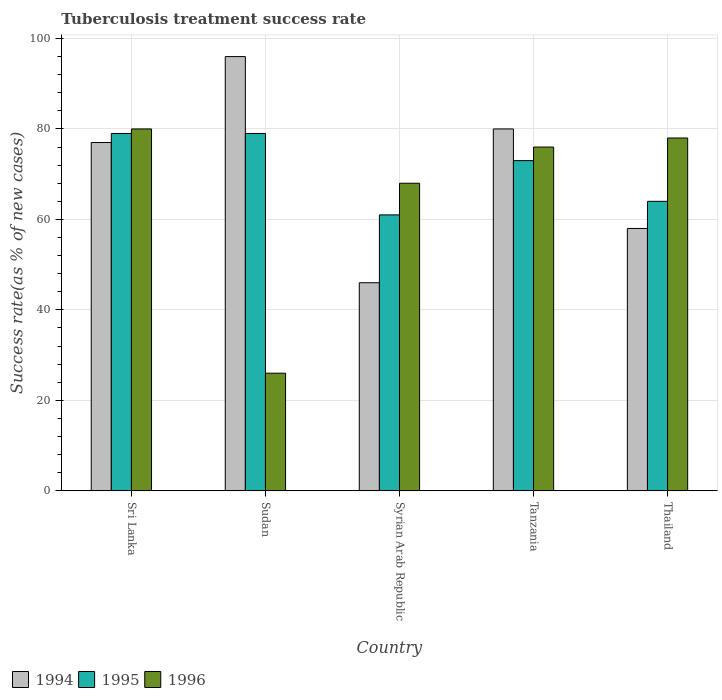How many groups of bars are there?
Make the answer very short. 5. How many bars are there on the 3rd tick from the left?
Keep it short and to the point. 3. How many bars are there on the 5th tick from the right?
Make the answer very short. 3. What is the label of the 4th group of bars from the left?
Give a very brief answer. Tanzania. Across all countries, what is the maximum tuberculosis treatment success rate in 1994?
Your answer should be very brief. 96. Across all countries, what is the minimum tuberculosis treatment success rate in 1995?
Offer a very short reply. 61. In which country was the tuberculosis treatment success rate in 1995 maximum?
Offer a very short reply. Sri Lanka. In which country was the tuberculosis treatment success rate in 1996 minimum?
Ensure brevity in your answer.  Sudan. What is the total tuberculosis treatment success rate in 1995 in the graph?
Ensure brevity in your answer.  356. What is the average tuberculosis treatment success rate in 1996 per country?
Keep it short and to the point. 65.6. What is the difference between the tuberculosis treatment success rate of/in 1995 and tuberculosis treatment success rate of/in 1996 in Syrian Arab Republic?
Make the answer very short. -7. What is the ratio of the tuberculosis treatment success rate in 1996 in Sudan to that in Tanzania?
Give a very brief answer. 0.34. Is the difference between the tuberculosis treatment success rate in 1995 in Syrian Arab Republic and Thailand greater than the difference between the tuberculosis treatment success rate in 1996 in Syrian Arab Republic and Thailand?
Provide a short and direct response. Yes. What is the difference between the highest and the lowest tuberculosis treatment success rate in 1994?
Provide a short and direct response. 50. Is the sum of the tuberculosis treatment success rate in 1995 in Sri Lanka and Thailand greater than the maximum tuberculosis treatment success rate in 1994 across all countries?
Your response must be concise. Yes. What does the 2nd bar from the left in Tanzania represents?
Offer a very short reply. 1995. What does the 2nd bar from the right in Sudan represents?
Make the answer very short. 1995. Is it the case that in every country, the sum of the tuberculosis treatment success rate in 1995 and tuberculosis treatment success rate in 1994 is greater than the tuberculosis treatment success rate in 1996?
Give a very brief answer. Yes. How many bars are there?
Your answer should be very brief. 15. Are all the bars in the graph horizontal?
Provide a succinct answer. No. Does the graph contain any zero values?
Your answer should be compact. No. Where does the legend appear in the graph?
Your response must be concise. Bottom left. How many legend labels are there?
Ensure brevity in your answer.  3. How are the legend labels stacked?
Offer a very short reply. Horizontal. What is the title of the graph?
Ensure brevity in your answer.  Tuberculosis treatment success rate. What is the label or title of the Y-axis?
Offer a terse response. Success rate(as % of new cases). What is the Success rate(as % of new cases) of 1995 in Sri Lanka?
Offer a very short reply. 79. What is the Success rate(as % of new cases) of 1996 in Sri Lanka?
Offer a terse response. 80. What is the Success rate(as % of new cases) in 1994 in Sudan?
Your answer should be compact. 96. What is the Success rate(as % of new cases) of 1995 in Sudan?
Your answer should be compact. 79. What is the Success rate(as % of new cases) of 1996 in Sudan?
Your response must be concise. 26. What is the Success rate(as % of new cases) in 1994 in Tanzania?
Your answer should be very brief. 80. What is the Success rate(as % of new cases) in 1995 in Tanzania?
Provide a succinct answer. 73. What is the Success rate(as % of new cases) of 1996 in Tanzania?
Your response must be concise. 76. What is the Success rate(as % of new cases) of 1994 in Thailand?
Keep it short and to the point. 58. What is the Success rate(as % of new cases) in 1996 in Thailand?
Ensure brevity in your answer.  78. Across all countries, what is the maximum Success rate(as % of new cases) in 1994?
Provide a succinct answer. 96. Across all countries, what is the maximum Success rate(as % of new cases) of 1995?
Your answer should be very brief. 79. Across all countries, what is the minimum Success rate(as % of new cases) of 1996?
Make the answer very short. 26. What is the total Success rate(as % of new cases) of 1994 in the graph?
Your answer should be compact. 357. What is the total Success rate(as % of new cases) in 1995 in the graph?
Provide a short and direct response. 356. What is the total Success rate(as % of new cases) in 1996 in the graph?
Your answer should be compact. 328. What is the difference between the Success rate(as % of new cases) in 1996 in Sri Lanka and that in Sudan?
Give a very brief answer. 54. What is the difference between the Success rate(as % of new cases) in 1996 in Sri Lanka and that in Syrian Arab Republic?
Keep it short and to the point. 12. What is the difference between the Success rate(as % of new cases) in 1994 in Sri Lanka and that in Tanzania?
Offer a terse response. -3. What is the difference between the Success rate(as % of new cases) in 1995 in Sri Lanka and that in Tanzania?
Provide a short and direct response. 6. What is the difference between the Success rate(as % of new cases) of 1994 in Sri Lanka and that in Thailand?
Offer a very short reply. 19. What is the difference between the Success rate(as % of new cases) of 1995 in Sri Lanka and that in Thailand?
Offer a terse response. 15. What is the difference between the Success rate(as % of new cases) in 1996 in Sri Lanka and that in Thailand?
Keep it short and to the point. 2. What is the difference between the Success rate(as % of new cases) in 1996 in Sudan and that in Syrian Arab Republic?
Provide a succinct answer. -42. What is the difference between the Success rate(as % of new cases) in 1994 in Sudan and that in Tanzania?
Ensure brevity in your answer.  16. What is the difference between the Success rate(as % of new cases) in 1996 in Sudan and that in Tanzania?
Your answer should be compact. -50. What is the difference between the Success rate(as % of new cases) in 1996 in Sudan and that in Thailand?
Offer a very short reply. -52. What is the difference between the Success rate(as % of new cases) in 1994 in Syrian Arab Republic and that in Tanzania?
Your response must be concise. -34. What is the difference between the Success rate(as % of new cases) in 1995 in Syrian Arab Republic and that in Thailand?
Ensure brevity in your answer.  -3. What is the difference between the Success rate(as % of new cases) of 1994 in Tanzania and that in Thailand?
Provide a short and direct response. 22. What is the difference between the Success rate(as % of new cases) of 1994 in Sri Lanka and the Success rate(as % of new cases) of 1995 in Sudan?
Your response must be concise. -2. What is the difference between the Success rate(as % of new cases) of 1994 in Sri Lanka and the Success rate(as % of new cases) of 1996 in Sudan?
Provide a short and direct response. 51. What is the difference between the Success rate(as % of new cases) of 1995 in Sri Lanka and the Success rate(as % of new cases) of 1996 in Sudan?
Provide a succinct answer. 53. What is the difference between the Success rate(as % of new cases) of 1994 in Sri Lanka and the Success rate(as % of new cases) of 1995 in Syrian Arab Republic?
Ensure brevity in your answer.  16. What is the difference between the Success rate(as % of new cases) in 1995 in Sri Lanka and the Success rate(as % of new cases) in 1996 in Tanzania?
Offer a terse response. 3. What is the difference between the Success rate(as % of new cases) in 1994 in Sri Lanka and the Success rate(as % of new cases) in 1996 in Thailand?
Give a very brief answer. -1. What is the difference between the Success rate(as % of new cases) of 1994 in Sudan and the Success rate(as % of new cases) of 1996 in Syrian Arab Republic?
Give a very brief answer. 28. What is the difference between the Success rate(as % of new cases) in 1994 in Sudan and the Success rate(as % of new cases) in 1995 in Tanzania?
Make the answer very short. 23. What is the difference between the Success rate(as % of new cases) of 1995 in Sudan and the Success rate(as % of new cases) of 1996 in Tanzania?
Your answer should be very brief. 3. What is the difference between the Success rate(as % of new cases) in 1994 in Sudan and the Success rate(as % of new cases) in 1995 in Thailand?
Your answer should be compact. 32. What is the difference between the Success rate(as % of new cases) of 1994 in Syrian Arab Republic and the Success rate(as % of new cases) of 1995 in Tanzania?
Your answer should be very brief. -27. What is the difference between the Success rate(as % of new cases) of 1994 in Syrian Arab Republic and the Success rate(as % of new cases) of 1996 in Tanzania?
Provide a short and direct response. -30. What is the difference between the Success rate(as % of new cases) in 1994 in Syrian Arab Republic and the Success rate(as % of new cases) in 1995 in Thailand?
Make the answer very short. -18. What is the difference between the Success rate(as % of new cases) in 1994 in Syrian Arab Republic and the Success rate(as % of new cases) in 1996 in Thailand?
Offer a terse response. -32. What is the difference between the Success rate(as % of new cases) in 1994 in Tanzania and the Success rate(as % of new cases) in 1995 in Thailand?
Make the answer very short. 16. What is the average Success rate(as % of new cases) in 1994 per country?
Give a very brief answer. 71.4. What is the average Success rate(as % of new cases) of 1995 per country?
Make the answer very short. 71.2. What is the average Success rate(as % of new cases) of 1996 per country?
Your response must be concise. 65.6. What is the difference between the Success rate(as % of new cases) of 1994 and Success rate(as % of new cases) of 1995 in Sudan?
Make the answer very short. 17. What is the difference between the Success rate(as % of new cases) of 1994 and Success rate(as % of new cases) of 1996 in Sudan?
Your answer should be compact. 70. What is the difference between the Success rate(as % of new cases) of 1994 and Success rate(as % of new cases) of 1995 in Syrian Arab Republic?
Your answer should be compact. -15. What is the difference between the Success rate(as % of new cases) in 1994 and Success rate(as % of new cases) in 1996 in Syrian Arab Republic?
Your response must be concise. -22. What is the difference between the Success rate(as % of new cases) of 1995 and Success rate(as % of new cases) of 1996 in Syrian Arab Republic?
Offer a terse response. -7. What is the difference between the Success rate(as % of new cases) in 1994 and Success rate(as % of new cases) in 1995 in Tanzania?
Keep it short and to the point. 7. What is the difference between the Success rate(as % of new cases) in 1994 and Success rate(as % of new cases) in 1996 in Tanzania?
Your answer should be compact. 4. What is the difference between the Success rate(as % of new cases) of 1994 and Success rate(as % of new cases) of 1995 in Thailand?
Offer a terse response. -6. What is the difference between the Success rate(as % of new cases) in 1994 and Success rate(as % of new cases) in 1996 in Thailand?
Your response must be concise. -20. What is the ratio of the Success rate(as % of new cases) of 1994 in Sri Lanka to that in Sudan?
Ensure brevity in your answer.  0.8. What is the ratio of the Success rate(as % of new cases) of 1996 in Sri Lanka to that in Sudan?
Offer a terse response. 3.08. What is the ratio of the Success rate(as % of new cases) in 1994 in Sri Lanka to that in Syrian Arab Republic?
Offer a very short reply. 1.67. What is the ratio of the Success rate(as % of new cases) of 1995 in Sri Lanka to that in Syrian Arab Republic?
Provide a short and direct response. 1.3. What is the ratio of the Success rate(as % of new cases) of 1996 in Sri Lanka to that in Syrian Arab Republic?
Your response must be concise. 1.18. What is the ratio of the Success rate(as % of new cases) in 1994 in Sri Lanka to that in Tanzania?
Offer a very short reply. 0.96. What is the ratio of the Success rate(as % of new cases) in 1995 in Sri Lanka to that in Tanzania?
Offer a very short reply. 1.08. What is the ratio of the Success rate(as % of new cases) of 1996 in Sri Lanka to that in Tanzania?
Provide a short and direct response. 1.05. What is the ratio of the Success rate(as % of new cases) of 1994 in Sri Lanka to that in Thailand?
Your answer should be very brief. 1.33. What is the ratio of the Success rate(as % of new cases) of 1995 in Sri Lanka to that in Thailand?
Ensure brevity in your answer.  1.23. What is the ratio of the Success rate(as % of new cases) of 1996 in Sri Lanka to that in Thailand?
Give a very brief answer. 1.03. What is the ratio of the Success rate(as % of new cases) of 1994 in Sudan to that in Syrian Arab Republic?
Offer a very short reply. 2.09. What is the ratio of the Success rate(as % of new cases) in 1995 in Sudan to that in Syrian Arab Republic?
Keep it short and to the point. 1.3. What is the ratio of the Success rate(as % of new cases) of 1996 in Sudan to that in Syrian Arab Republic?
Keep it short and to the point. 0.38. What is the ratio of the Success rate(as % of new cases) of 1994 in Sudan to that in Tanzania?
Offer a terse response. 1.2. What is the ratio of the Success rate(as % of new cases) in 1995 in Sudan to that in Tanzania?
Provide a succinct answer. 1.08. What is the ratio of the Success rate(as % of new cases) in 1996 in Sudan to that in Tanzania?
Provide a succinct answer. 0.34. What is the ratio of the Success rate(as % of new cases) of 1994 in Sudan to that in Thailand?
Your answer should be very brief. 1.66. What is the ratio of the Success rate(as % of new cases) of 1995 in Sudan to that in Thailand?
Provide a short and direct response. 1.23. What is the ratio of the Success rate(as % of new cases) of 1996 in Sudan to that in Thailand?
Give a very brief answer. 0.33. What is the ratio of the Success rate(as % of new cases) of 1994 in Syrian Arab Republic to that in Tanzania?
Provide a short and direct response. 0.57. What is the ratio of the Success rate(as % of new cases) in 1995 in Syrian Arab Republic to that in Tanzania?
Make the answer very short. 0.84. What is the ratio of the Success rate(as % of new cases) in 1996 in Syrian Arab Republic to that in Tanzania?
Make the answer very short. 0.89. What is the ratio of the Success rate(as % of new cases) of 1994 in Syrian Arab Republic to that in Thailand?
Provide a succinct answer. 0.79. What is the ratio of the Success rate(as % of new cases) in 1995 in Syrian Arab Republic to that in Thailand?
Provide a succinct answer. 0.95. What is the ratio of the Success rate(as % of new cases) in 1996 in Syrian Arab Republic to that in Thailand?
Your response must be concise. 0.87. What is the ratio of the Success rate(as % of new cases) in 1994 in Tanzania to that in Thailand?
Your response must be concise. 1.38. What is the ratio of the Success rate(as % of new cases) in 1995 in Tanzania to that in Thailand?
Provide a short and direct response. 1.14. What is the ratio of the Success rate(as % of new cases) of 1996 in Tanzania to that in Thailand?
Give a very brief answer. 0.97. What is the difference between the highest and the second highest Success rate(as % of new cases) in 1994?
Provide a short and direct response. 16. What is the difference between the highest and the second highest Success rate(as % of new cases) in 1995?
Keep it short and to the point. 0. What is the difference between the highest and the second highest Success rate(as % of new cases) of 1996?
Your response must be concise. 2. What is the difference between the highest and the lowest Success rate(as % of new cases) of 1994?
Make the answer very short. 50. What is the difference between the highest and the lowest Success rate(as % of new cases) of 1996?
Provide a succinct answer. 54. 